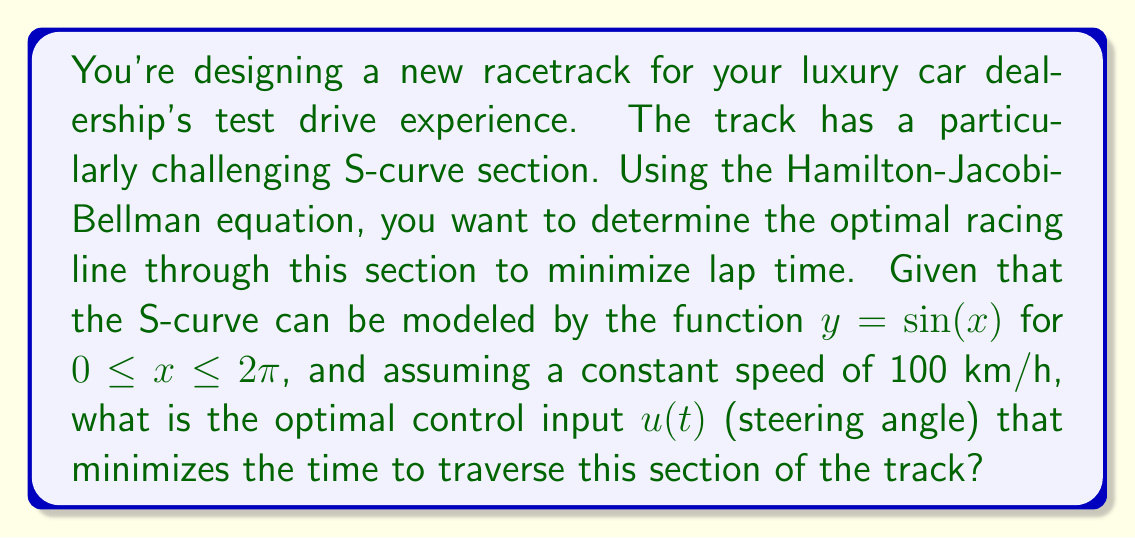Give your solution to this math problem. To solve this problem, we'll use the Hamilton-Jacobi-Bellman (HJB) equation, which is a fundamental equation in optimal control theory. Let's break this down step-by-step:

1) First, we need to define our state variables. Let $x$ and $y$ be the position coordinates on the track, and $\theta$ be the angle of the car's velocity vector with respect to the x-axis.

2) The system dynamics can be described by:

   $$\dot{x} = v \cos(\theta)$$
   $$\dot{y} = v \sin(\theta)$$
   $$\dot{\theta} = u$$

   where $v$ is the constant speed (100 km/h) and $u$ is our control input (steering angle).

3) Our objective is to minimize the time to traverse the curve, so our cost function is simply:

   $$J = \int_0^T dt = T$$

4) The HJB equation for this problem is:

   $$-\frac{\partial V}{\partial t} = \min_u \left\{1 + \frac{\partial V}{\partial x}v\cos(\theta) + \frac{\partial V}{\partial y}v\sin(\theta) + \frac{\partial V}{\partial \theta}u\right\}$$

   where $V(x,y,\theta,t)$ is the value function.

5) To minimize the right-hand side with respect to $u$, we set:

   $$\frac{\partial}{\partial u}\left\{1 + \frac{\partial V}{\partial x}v\cos(\theta) + \frac{\partial V}{\partial y}v\sin(\theta) + \frac{\partial V}{\partial \theta}u\right\} = 0$$

6) This gives us:

   $$\frac{\partial V}{\partial \theta} = 0$$

7) Substituting this back into the HJB equation:

   $$-\frac{\partial V}{\partial t} = 1 + \frac{\partial V}{\partial x}v\cos(\theta) + \frac{\partial V}{\partial y}v\sin(\theta)$$

8) Now, given that the track is described by $y = \sin(x)$, we can say that the optimal trajectory should follow this curve. This means:

   $$\frac{dy}{dx} = \cos(x) = \tan(\theta)$$

9) Therefore, the optimal steering angle $u(t)$ is:

   $$u(t) = \frac{d\theta}{dt} = \frac{d\theta}{dx} \cdot \frac{dx}{dt} = \frac{d}{dx}(\arctan(\cos(x))) \cdot v\cos(\theta)$$

10) Simplifying:

    $$u(t) = -\frac{\sin(x)}{1+\cos^2(x)} \cdot v\cos(\arctan(\cos(x)))$$

This is our optimal control input $u(t)$ as a function of $x$.
Answer: The optimal control input (steering angle) $u(t)$ is given by:

$$u(t) = -\frac{\sin(x)}{1+\cos^2(x)} \cdot v\cos(\arctan(\cos(x)))$$

where $x$ is the current x-coordinate on the track, and $v$ is the constant speed of 100 km/h. 